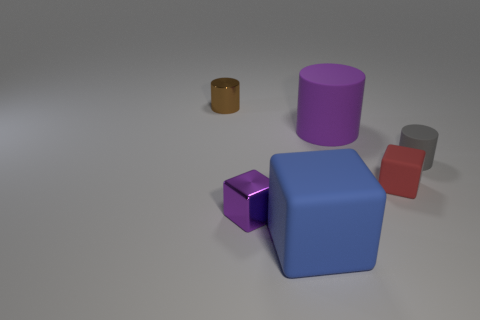Is there a matte object that has the same color as the shiny block?
Your answer should be compact. Yes. Do the purple object that is right of the large blue cube and the thing that is left of the metallic block have the same shape?
Give a very brief answer. Yes. How many objects are metal blocks or small objects that are in front of the red rubber thing?
Keep it short and to the point. 1. There is a small thing that is behind the shiny cube and left of the red block; what material is it?
Keep it short and to the point. Metal. There is another thing that is made of the same material as the tiny purple object; what is its color?
Provide a succinct answer. Brown. What number of things are big red objects or large blue blocks?
Offer a terse response. 1. Do the purple cylinder and the shiny object that is behind the gray cylinder have the same size?
Give a very brief answer. No. What color is the shiny object on the right side of the tiny cylinder that is to the left of the small cylinder in front of the shiny cylinder?
Your answer should be compact. Purple. The small shiny cylinder has what color?
Keep it short and to the point. Brown. Are there more purple metallic objects left of the metallic cylinder than tiny things that are behind the big blue cube?
Keep it short and to the point. No. 